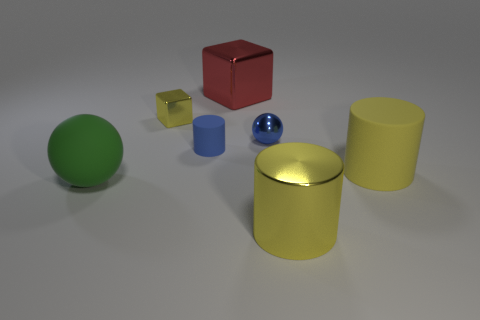Subtract all green cubes. How many yellow cylinders are left? 2 Subtract all large yellow cylinders. How many cylinders are left? 1 Subtract 1 cylinders. How many cylinders are left? 2 Add 1 yellow cylinders. How many objects exist? 8 Subtract all cubes. How many objects are left? 5 Subtract all purple cylinders. Subtract all yellow blocks. How many cylinders are left? 3 Subtract 0 red spheres. How many objects are left? 7 Subtract all yellow cylinders. Subtract all large purple metal cylinders. How many objects are left? 5 Add 2 blue balls. How many blue balls are left? 3 Add 5 red cubes. How many red cubes exist? 6 